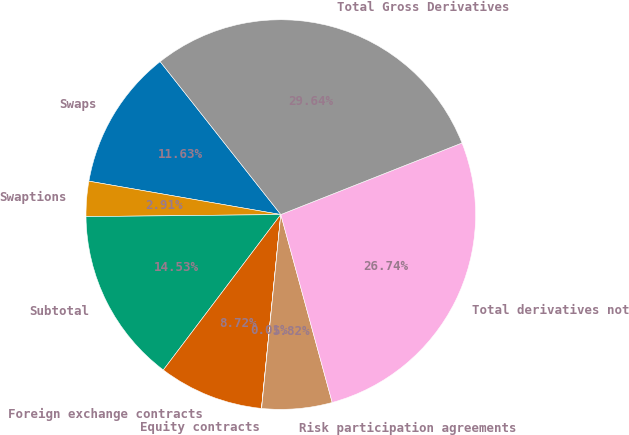<chart> <loc_0><loc_0><loc_500><loc_500><pie_chart><fcel>Swaps<fcel>Swaptions<fcel>Subtotal<fcel>Foreign exchange contracts<fcel>Equity contracts<fcel>Risk participation agreements<fcel>Total derivatives not<fcel>Total Gross Derivatives<nl><fcel>11.63%<fcel>2.91%<fcel>14.53%<fcel>8.72%<fcel>0.01%<fcel>5.82%<fcel>26.74%<fcel>29.64%<nl></chart> 